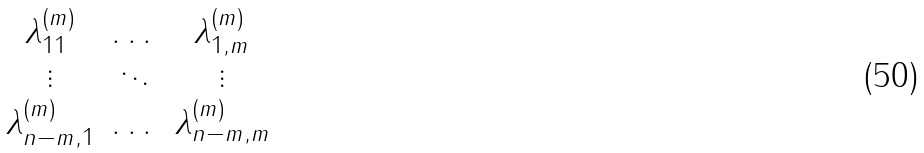Convert formula to latex. <formula><loc_0><loc_0><loc_500><loc_500>\begin{matrix} \lambda ^ { ( m ) } _ { 1 1 } & \dots & \lambda ^ { ( m ) } _ { 1 , m } \\ \vdots & \ddots & \vdots \\ \lambda ^ { ( m ) } _ { n - m , 1 } & \dots & \lambda ^ { ( m ) } _ { n - m , m } \end{matrix}</formula> 